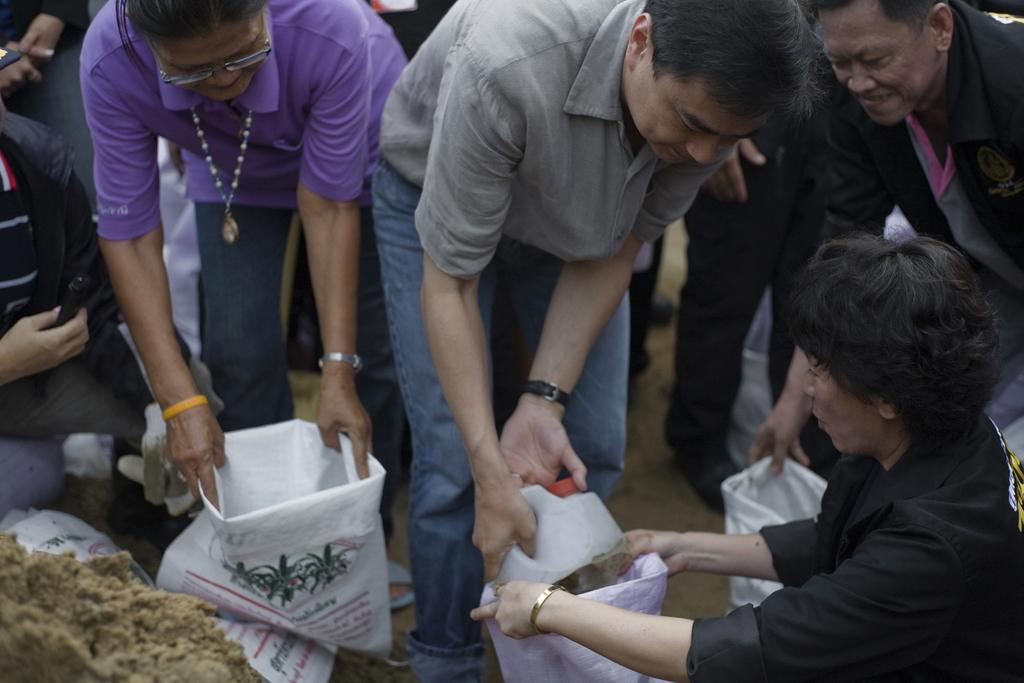What is the main subject of the image? The main subject of the image is a group of people. Can you describe the actions of some people in the group? Some people in the group are bending. What are some people in the group holding? Some people in the group are holding bags in their hands. How many horses can be seen in the image? There are no horses present in the image. What type of chicken is being held by one of the people in the image? There are no chickens present in the image. 